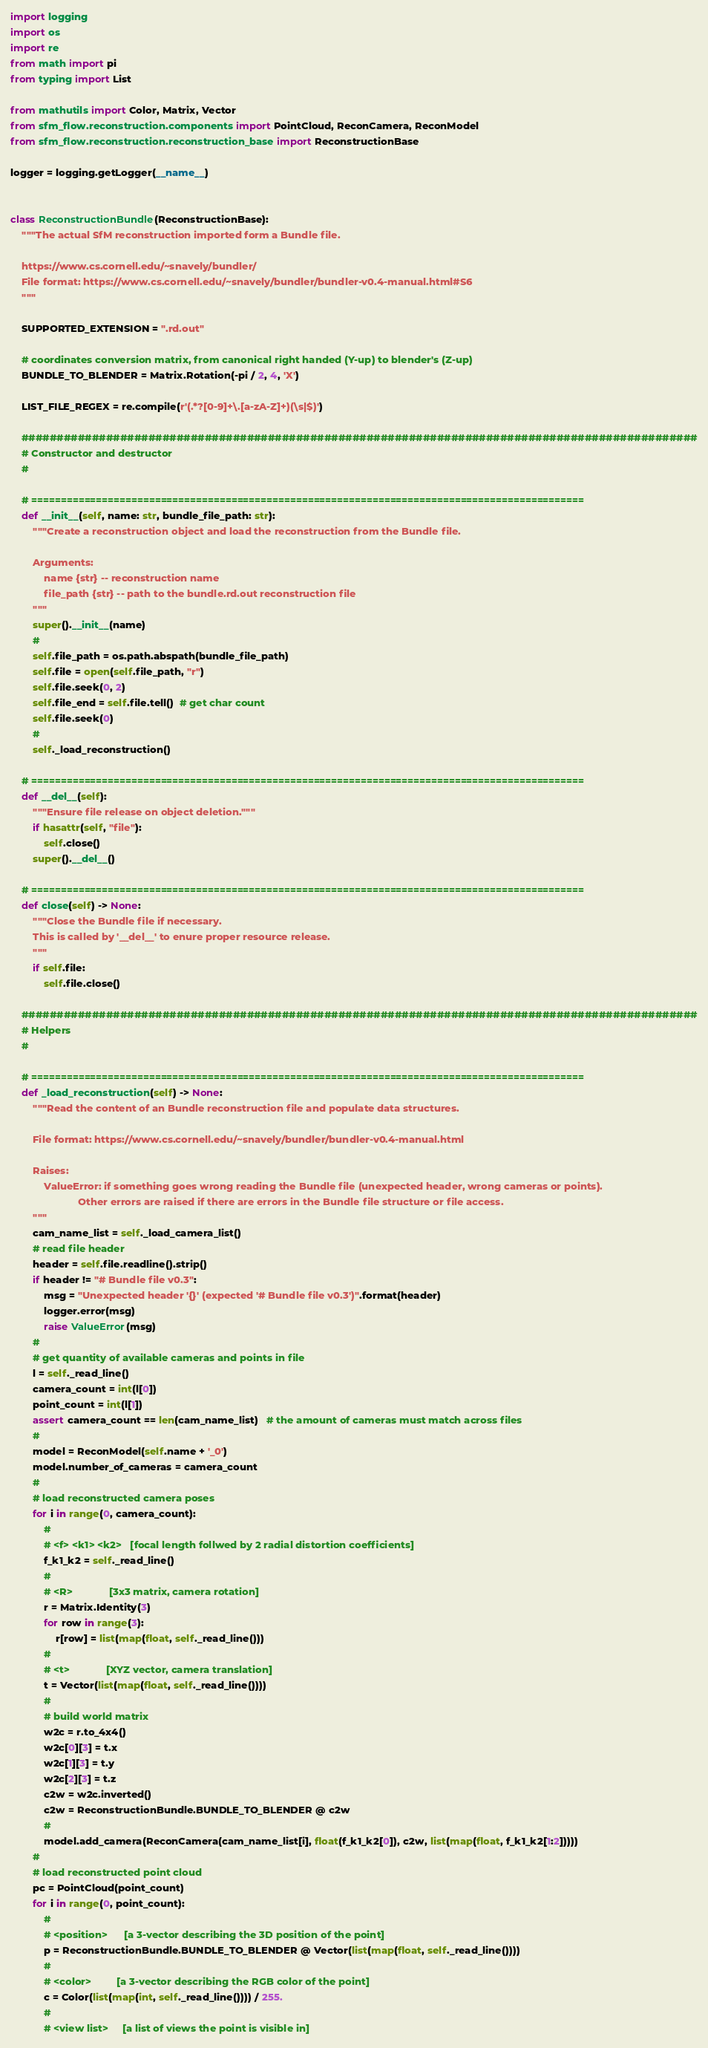Convert code to text. <code><loc_0><loc_0><loc_500><loc_500><_Python_>
import logging
import os
import re
from math import pi
from typing import List

from mathutils import Color, Matrix, Vector
from sfm_flow.reconstruction.components import PointCloud, ReconCamera, ReconModel
from sfm_flow.reconstruction.reconstruction_base import ReconstructionBase

logger = logging.getLogger(__name__)


class ReconstructionBundle(ReconstructionBase):
    """The actual SfM reconstruction imported form a Bundle file.

    https://www.cs.cornell.edu/~snavely/bundler/
    File format: https://www.cs.cornell.edu/~snavely/bundler/bundler-v0.4-manual.html#S6
    """

    SUPPORTED_EXTENSION = ".rd.out"

    # coordinates conversion matrix, from canonical right handed (Y-up) to blender's (Z-up)
    BUNDLE_TO_BLENDER = Matrix.Rotation(-pi / 2, 4, 'X')

    LIST_FILE_REGEX = re.compile(r'(.*?[0-9]+\.[a-zA-Z]+)(\s|$)')

    ################################################################################################
    # Constructor and destructor
    #

    # ==============================================================================================
    def __init__(self, name: str, bundle_file_path: str):
        """Create a reconstruction object and load the reconstruction from the Bundle file.

        Arguments:
            name {str} -- reconstruction name
            file_path {str} -- path to the bundle.rd.out reconstruction file
        """
        super().__init__(name)
        #
        self.file_path = os.path.abspath(bundle_file_path)
        self.file = open(self.file_path, "r")
        self.file.seek(0, 2)
        self.file_end = self.file.tell()  # get char count
        self.file.seek(0)
        #
        self._load_reconstruction()

    # ==============================================================================================
    def __del__(self):
        """Ensure file release on object deletion."""
        if hasattr(self, "file"):
            self.close()
        super().__del__()

    # ==============================================================================================
    def close(self) -> None:
        """Close the Bundle file if necessary.
        This is called by '__del__' to enure proper resource release.
        """
        if self.file:
            self.file.close()

    ################################################################################################
    # Helpers
    #

    # ==============================================================================================
    def _load_reconstruction(self) -> None:
        """Read the content of an Bundle reconstruction file and populate data structures.

        File format: https://www.cs.cornell.edu/~snavely/bundler/bundler-v0.4-manual.html

        Raises:
            ValueError: if something goes wrong reading the Bundle file (unexpected header, wrong cameras or points).
                        Other errors are raised if there are errors in the Bundle file structure or file access.
        """
        cam_name_list = self._load_camera_list()
        # read file header
        header = self.file.readline().strip()
        if header != "# Bundle file v0.3":
            msg = "Unexpected header '{}' (expected '# Bundle file v0.3')".format(header)
            logger.error(msg)
            raise ValueError(msg)
        #
        # get quantity of available cameras and points in file
        l = self._read_line()
        camera_count = int(l[0])
        point_count = int(l[1])
        assert camera_count == len(cam_name_list)   # the amount of cameras must match across files
        #
        model = ReconModel(self.name + '_0')
        model.number_of_cameras = camera_count
        #
        # load reconstructed camera poses
        for i in range(0, camera_count):
            #
            # <f> <k1> <k2>   [focal length follwed by 2 radial distortion coefficients]
            f_k1_k2 = self._read_line()
            #
            # <R>             [3x3 matrix, camera rotation]
            r = Matrix.Identity(3)
            for row in range(3):
                r[row] = list(map(float, self._read_line()))
            #
            # <t>             [XYZ vector, camera translation]
            t = Vector(list(map(float, self._read_line())))
            #
            # build world matrix
            w2c = r.to_4x4()
            w2c[0][3] = t.x
            w2c[1][3] = t.y
            w2c[2][3] = t.z
            c2w = w2c.inverted()
            c2w = ReconstructionBundle.BUNDLE_TO_BLENDER @ c2w
            #
            model.add_camera(ReconCamera(cam_name_list[i], float(f_k1_k2[0]), c2w, list(map(float, f_k1_k2[1:2]))))
        #
        # load reconstructed point cloud
        pc = PointCloud(point_count)
        for i in range(0, point_count):
            #
            # <position>      [a 3-vector describing the 3D position of the point]
            p = ReconstructionBundle.BUNDLE_TO_BLENDER @ Vector(list(map(float, self._read_line())))
            #
            # <color>         [a 3-vector describing the RGB color of the point]
            c = Color(list(map(int, self._read_line()))) / 255.
            #
            # <view list>     [a list of views the point is visible in]</code> 